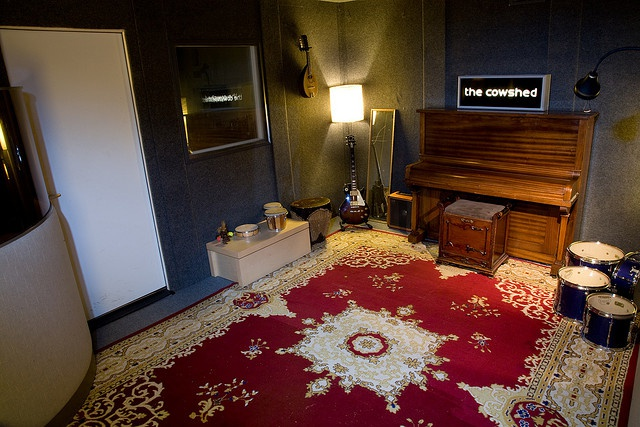Describe the objects in this image and their specific colors. I can see various objects in this image with different colors. 